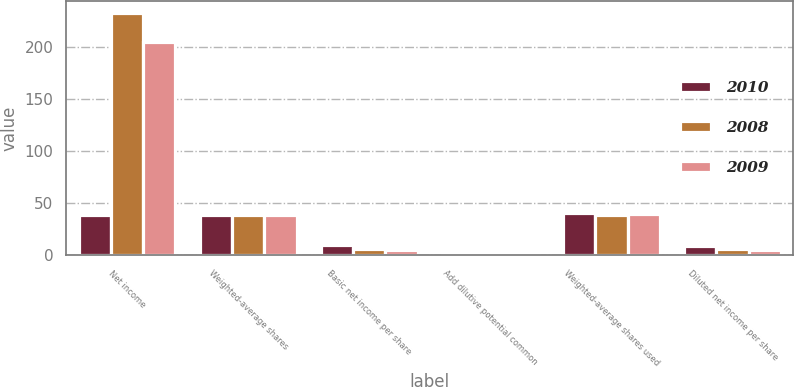<chart> <loc_0><loc_0><loc_500><loc_500><stacked_bar_chart><ecel><fcel>Net income<fcel>Weighted-average shares<fcel>Basic net income per share<fcel>Add dilutive potential common<fcel>Weighted-average shares used<fcel>Diluted net income per share<nl><fcel>2010<fcel>38.3<fcel>39.2<fcel>9.74<fcel>1.1<fcel>40.3<fcel>9.47<nl><fcel>2008<fcel>232.6<fcel>38.3<fcel>6.07<fcel>0.9<fcel>39.2<fcel>5.93<nl><fcel>2009<fcel>204.3<fcel>38.9<fcel>5.26<fcel>1<fcel>39.9<fcel>5.12<nl></chart> 